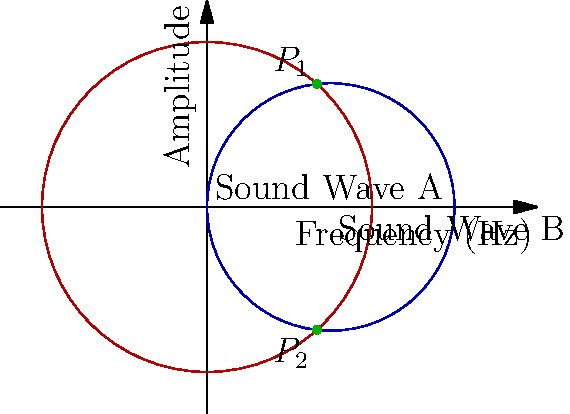In a frequency spectrum analysis of two overlapping sound waves from your vinyl collection, you observe two intersecting circles representing the waves' amplitudes across frequencies. Sound Wave A is centered at (0,0) with a radius of 4, while Sound Wave B is centered at (3,0) with a radius of 3. Calculate the y-coordinate of the upper intersection point $P_1$ of these two waves. Let's approach this step-by-step:

1) The equation of circle A (centered at (0,0) with radius 4) is:
   $$x^2 + y^2 = 16$$

2) The equation of circle B (centered at (3,0) with radius 3) is:
   $$(x-3)^2 + y^2 = 9$$

3) To find the intersection points, we need to solve these equations simultaneously:
   $$x^2 + y^2 = 16$$
   $$(x-3)^2 + y^2 = 9$$

4) Subtracting the second equation from the first:
   $$x^2 - (x-3)^2 = 16 - 9$$
   $$x^2 - (x^2 - 6x + 9) = 7$$
   $$6x - 9 = 7$$
   $$6x = 16$$
   $$x = \frac{8}{3}$$

5) Substitute this x-value back into the equation of circle A:
   $$(\frac{8}{3})^2 + y^2 = 16$$
   $$\frac{64}{9} + y^2 = 16$$
   $$y^2 = 16 - \frac{64}{9} = \frac{144-64}{9} = \frac{80}{9}$$

6) Take the square root of both sides:
   $$y = \pm \sqrt{\frac{80}{9}} = \pm \frac{2\sqrt{20}}{3}$$

7) The positive value gives us the y-coordinate of $P_1$:
   $$y = \frac{2\sqrt{20}}{3}$$
Answer: $\frac{2\sqrt{20}}{3}$ 